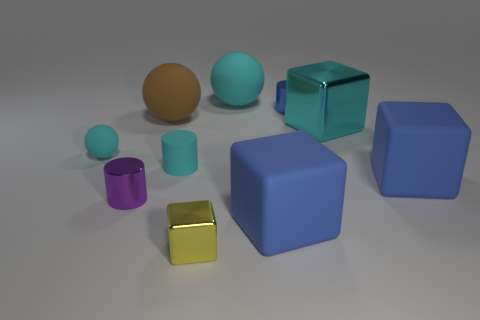There is a metal thing that is both in front of the blue metallic cylinder and right of the yellow metallic cube; what is its color?
Make the answer very short. Cyan. Is the number of purple cylinders greater than the number of big metal balls?
Your answer should be very brief. Yes. Do the small purple metal object that is to the left of the tiny metal cube and the yellow object have the same shape?
Ensure brevity in your answer.  No. How many matte objects are cyan cylinders or blue objects?
Ensure brevity in your answer.  3. Is there a tiny red sphere made of the same material as the tiny yellow object?
Provide a succinct answer. No. What is the small block made of?
Provide a succinct answer. Metal. There is a big blue thing that is left of the small cylinder that is behind the tiny cyan matte sphere that is in front of the big cyan shiny block; what is its shape?
Offer a very short reply. Cube. Are there more rubber balls that are in front of the small blue cylinder than cyan balls?
Ensure brevity in your answer.  No. There is a purple shiny object; does it have the same shape as the blue matte thing right of the big cyan block?
Ensure brevity in your answer.  No. What shape is the big rubber object that is the same color as the matte cylinder?
Your answer should be very brief. Sphere. 